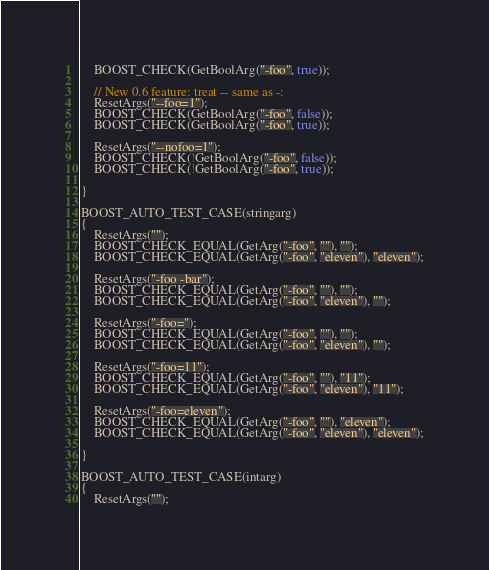<code> <loc_0><loc_0><loc_500><loc_500><_C++_>    BOOST_CHECK(GetBoolArg("-foo", true));

    // New 0.6 feature: treat -- same as -:
    ResetArgs("--foo=1");
    BOOST_CHECK(GetBoolArg("-foo", false));
    BOOST_CHECK(GetBoolArg("-foo", true));

    ResetArgs("--nofoo=1");
    BOOST_CHECK(!GetBoolArg("-foo", false));
    BOOST_CHECK(!GetBoolArg("-foo", true));

}

BOOST_AUTO_TEST_CASE(stringarg)
{
    ResetArgs("");
    BOOST_CHECK_EQUAL(GetArg("-foo", ""), "");
    BOOST_CHECK_EQUAL(GetArg("-foo", "eleven"), "eleven");

    ResetArgs("-foo -bar");
    BOOST_CHECK_EQUAL(GetArg("-foo", ""), "");
    BOOST_CHECK_EQUAL(GetArg("-foo", "eleven"), "");

    ResetArgs("-foo=");
    BOOST_CHECK_EQUAL(GetArg("-foo", ""), "");
    BOOST_CHECK_EQUAL(GetArg("-foo", "eleven"), "");

    ResetArgs("-foo=11");
    BOOST_CHECK_EQUAL(GetArg("-foo", ""), "11");
    BOOST_CHECK_EQUAL(GetArg("-foo", "eleven"), "11");

    ResetArgs("-foo=eleven");
    BOOST_CHECK_EQUAL(GetArg("-foo", ""), "eleven");
    BOOST_CHECK_EQUAL(GetArg("-foo", "eleven"), "eleven");

}

BOOST_AUTO_TEST_CASE(intarg)
{
    ResetArgs("");</code> 